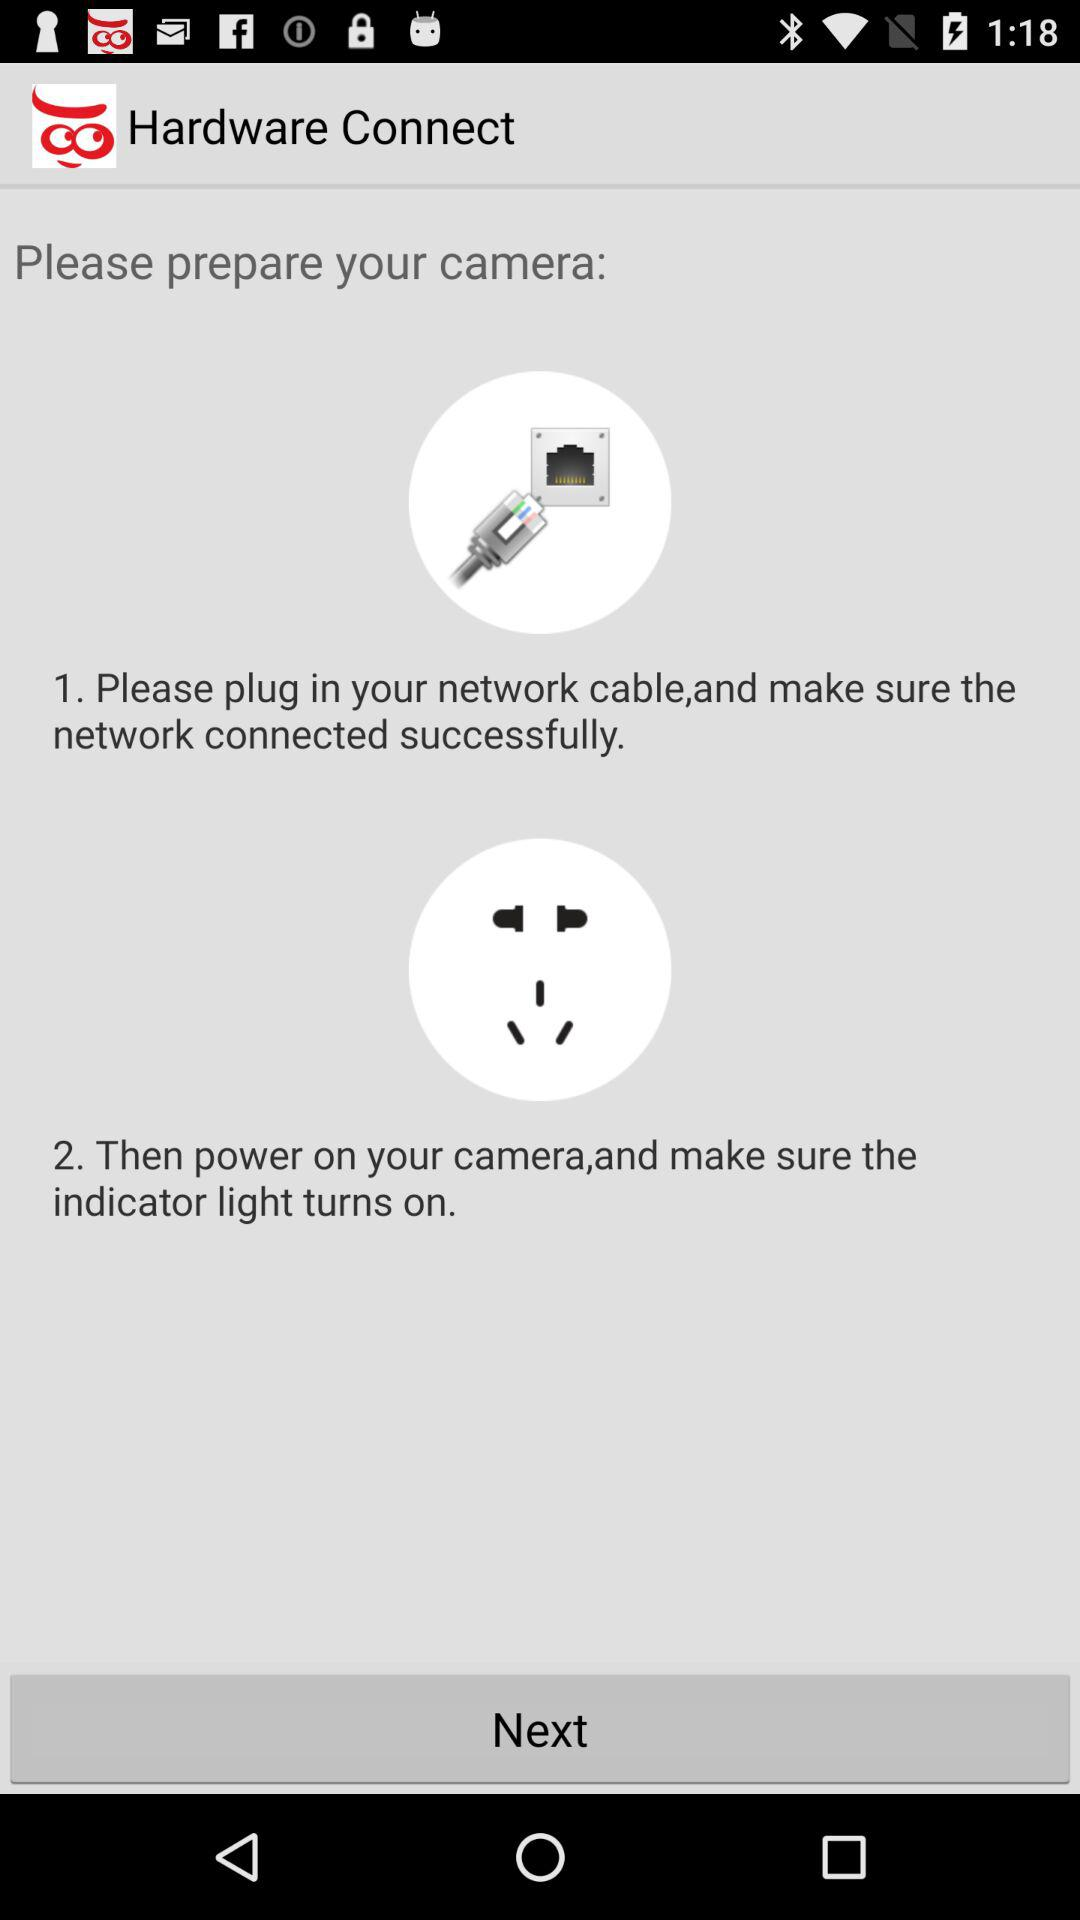What is the first stage of camera preparation?
Answer the question using a single word or phrase. The first stage of camera preparation is "Please plug in your network cable,and make sure the network connected successfully." 